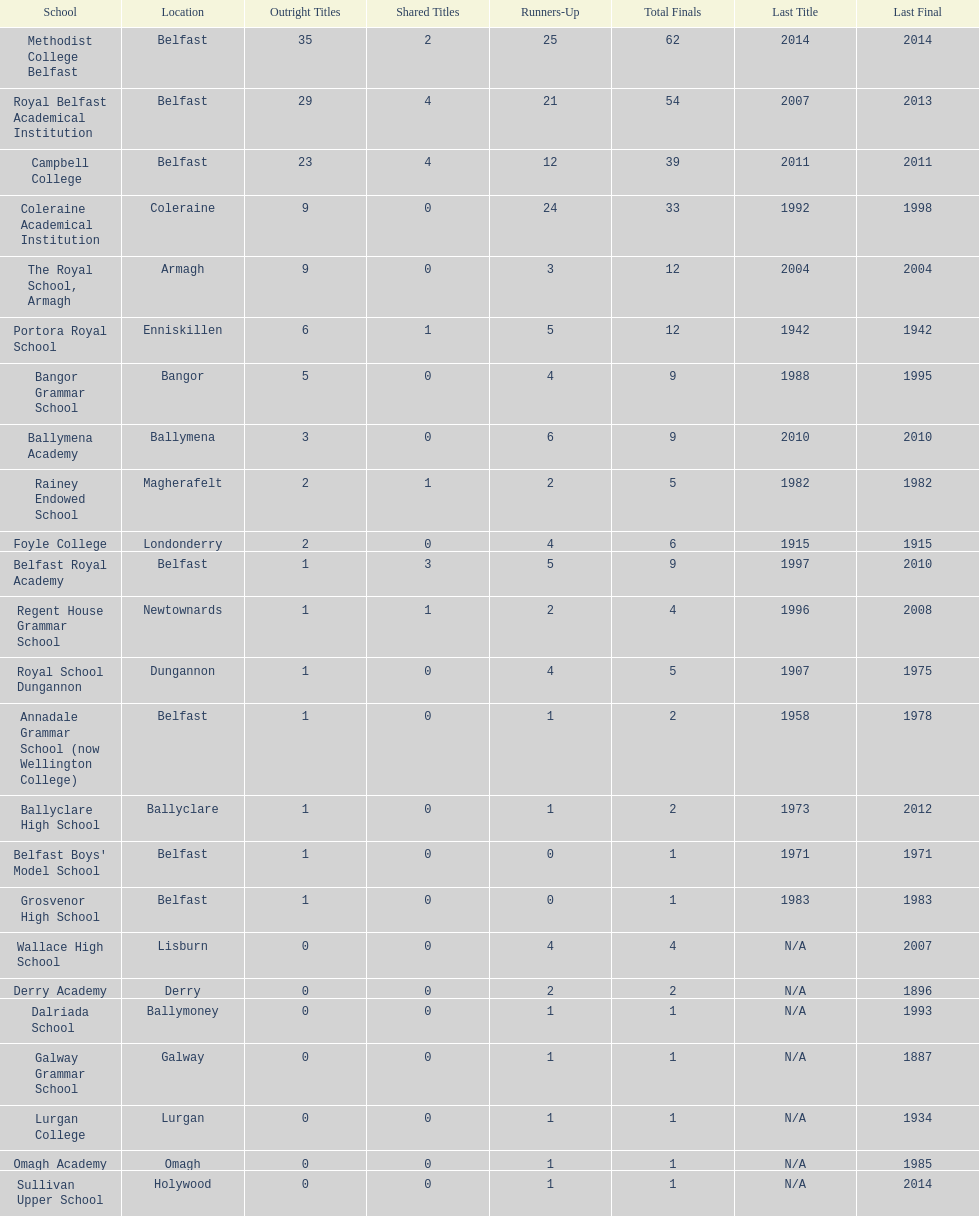What was the last year that the regent house grammar school won a title? 1996. 